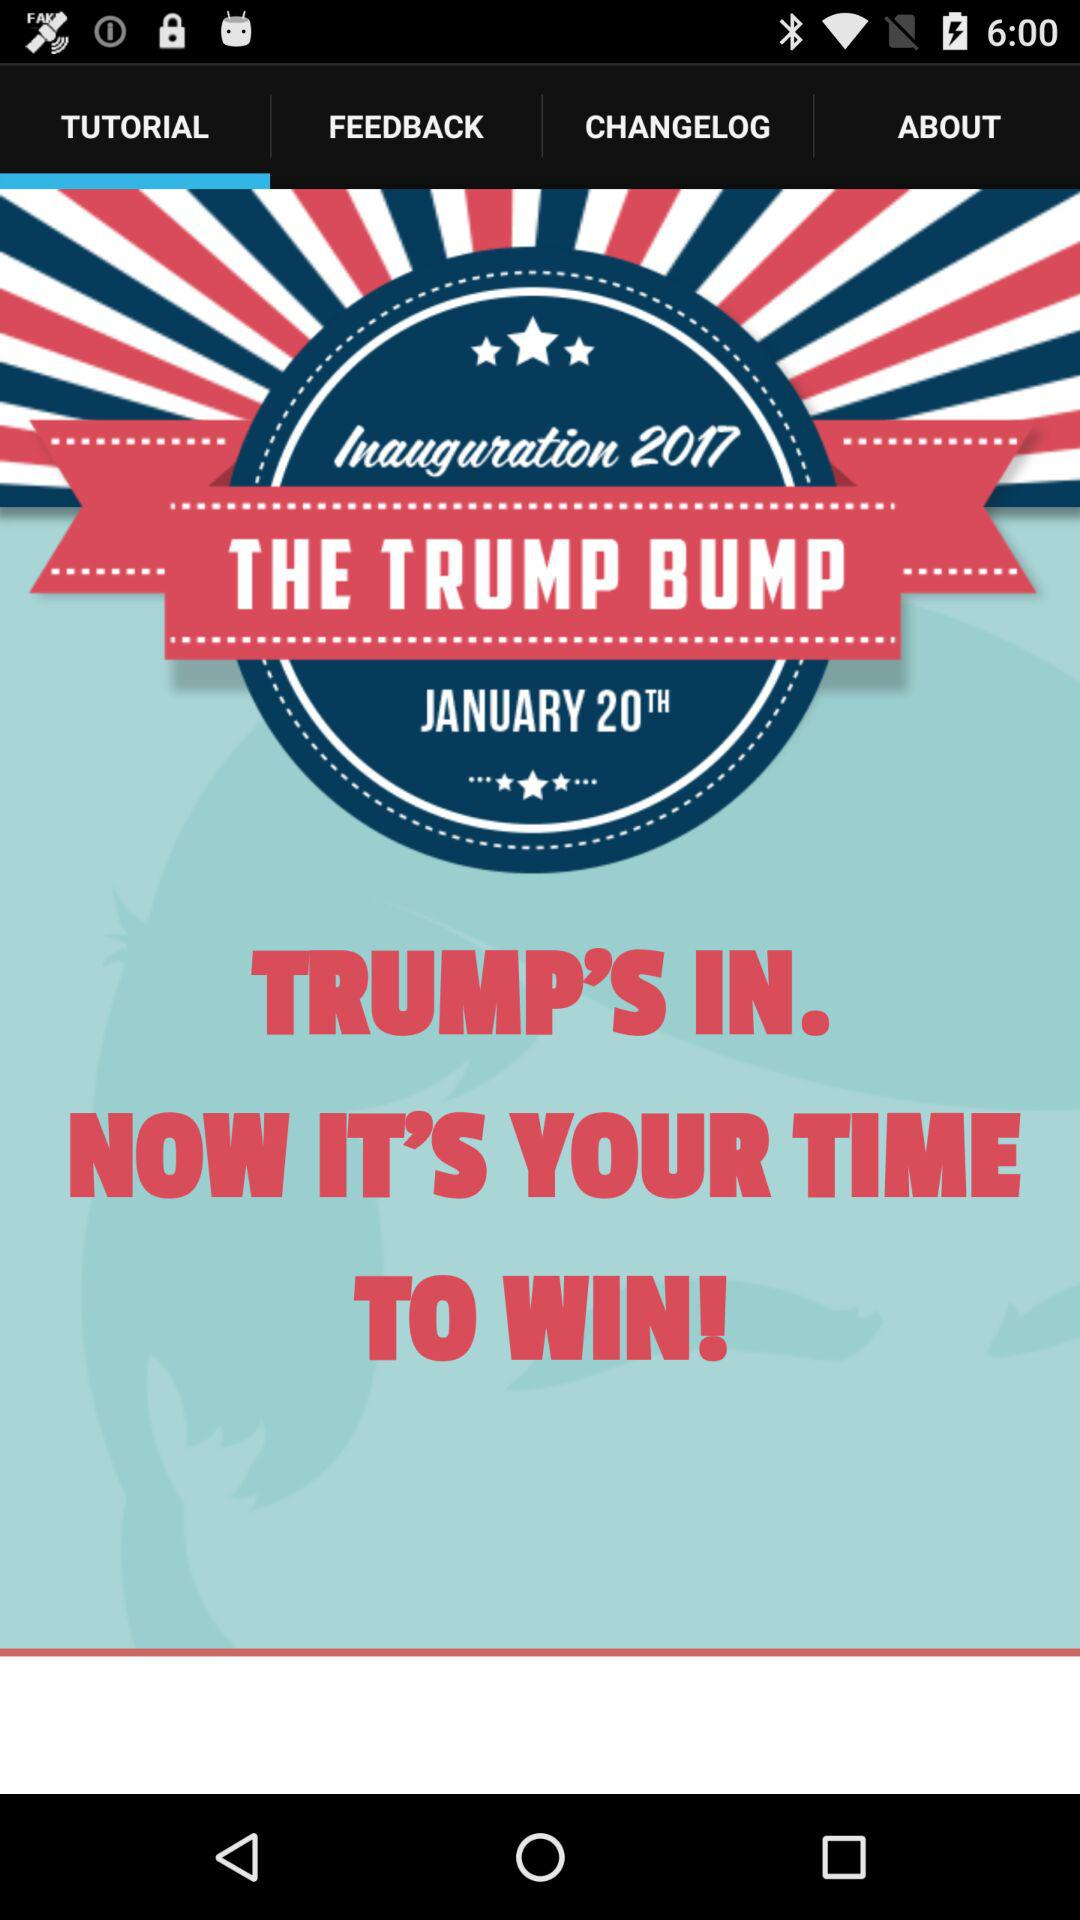What's the inauguration date? The inauguration date is January 20, 2017. 